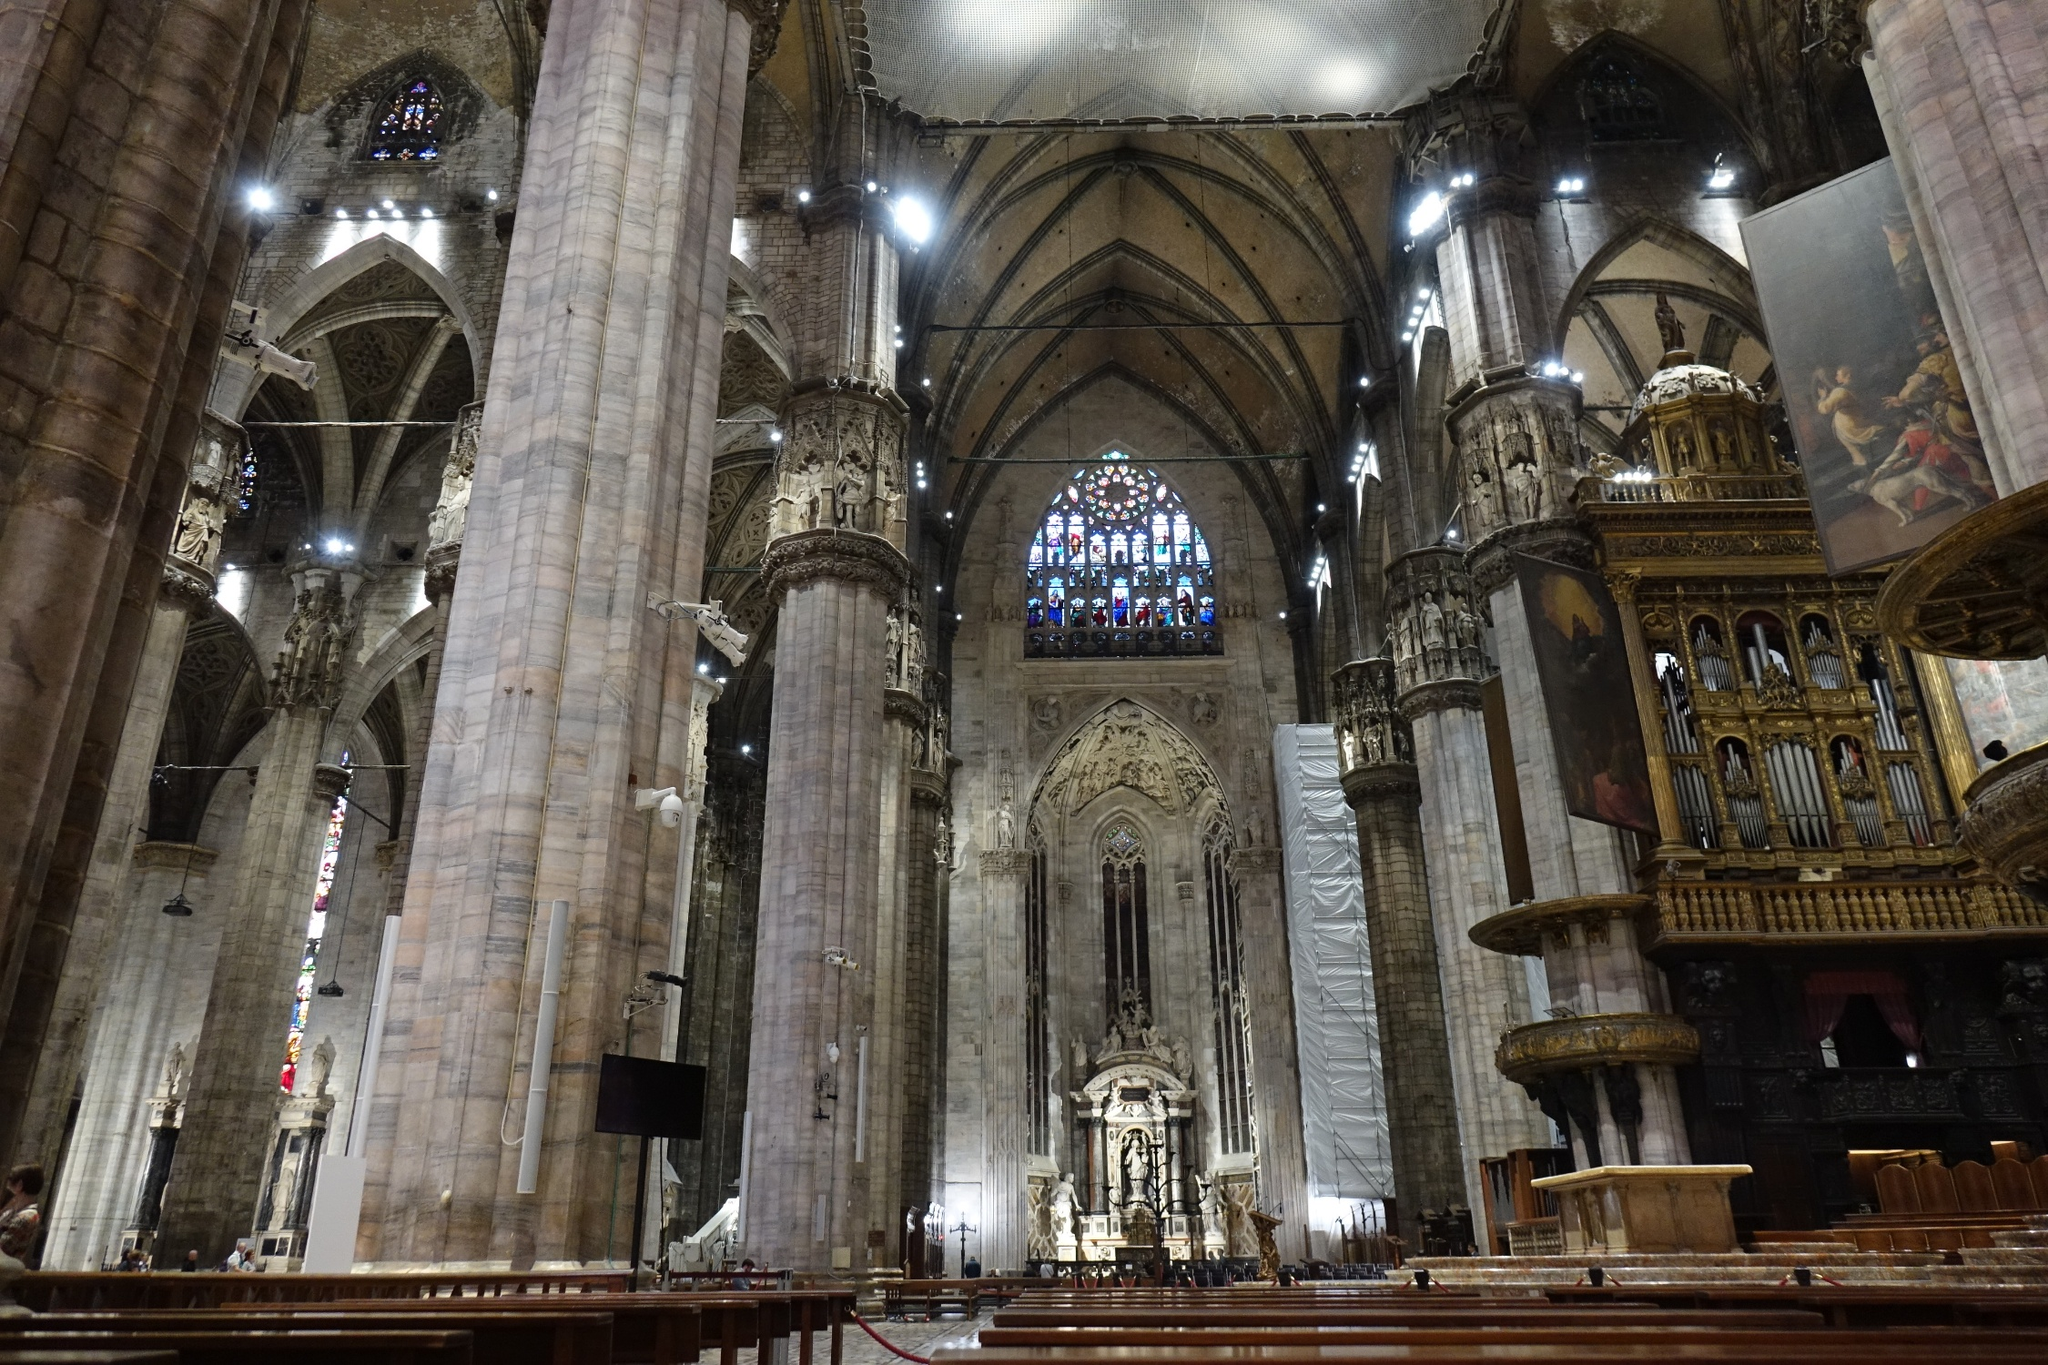Share your thoughts on the light and shadow interplay within this image. The interplay of light and shadow within this image is nothing short of mesmerizing. The stained glass windows introduce a spectrum of colors that merge with the natural light, creating a dappled effect on the stone surfaces. The light filtering in through the windows seems almost ethereal, casting shimmering patterns and emphasizing the grandeur of the architecture. Shadows, on the other hand, sculpt the columns and arches, adding depth and accentuating the intricate carvings. This dance between light and shadow not only enhances the visual appeal of the cathedral but also evokes a sense of mystery and reverence, reminding visitors of the sacred and historic significance of this space. Describe a realistic scenario of a tourist's visit to this cathedral. A tourist’s visit to the Milan Cathedral would start with awe as they approach the vast façade, admiring the detailed sculptures and numerous spires that adorn the exterior. Stepping inside, they would be struck by the immensity of the nave and the height of the columns, prompting them to pause and take in the breathtaking sight. As they wander down the aisle, they might stop to examine the intricate statues and carvings on each column, appreciating the craftsmanship. They would then take a moment to bask in the light coming through the stained glass windows, perhaps sitting quietly on a pew to absorb the cathedral’s serene atmosphere. If scaffolding is present, a guide might explain the ongoing restoration efforts to preserve the historical and architectural integrity of the structure. Before leaving, they would likely visit the altar, offering a silent prayer or simply reflecting on the beauty and history of this gothic marvel. Imagine a fantastical scenario where this cathedral suddenly transforms. How would it look and what might happen? Imagine the Milan Cathedral suddenly transforming into a magical realm. The stone columns become ancient trees, their branches reaching towards a star-lit sky instead of a vaulted ceiling. Vines adorned with glowing flowers intertwine with the arches, creating tunnels of light and color. The stained glass windows expand and reshape, telling not just religious stories but also tales of mythical creatures, heroes, and celestial beings. The statues come to life, gracefully moving and sharing their countless stories with visitors. Waterfalls emerge from hidden niches, flowing into crystal-clear pools that reflect the transformed surroundings. The altar becomes a radiant throne, not just of religious significance, but a symbol of unity and magic, drawing not just the faithful but creatures from various realms. Soft, ethereal music fills the air, created by an unseen choir of enchanted beings. This fantastical transformation invites all who enter to partake in a timeless adventure, merging the sacred with the magical in an unforgettable experience.  What elements in the image highlight the balance between art and architecture in the cathedral? Several elements in the image highlight the balance between art and architecture in the Milan Cathedral. The towering marble columns, while primarily structural, are adorned with intricate carvings and statues, merging functionality with artistic expression. The vaulted ceiling itself is not just an architectural feat, but an artwork, with its patterned designs and the stained glass windows that fill the space with vibrant light. The altar, both a religious and artistic focal point, showcases a blend of sculptural art and architectural elegance. Even the presence of the scaffolding subtly indicates the ongoing preservation of both the art and architecture, emphasizing the care taken to maintain this balance. This harmonious blend ensures that the cathedral is not just a place of worship but also a testament to human creativity and craftsmanship. 